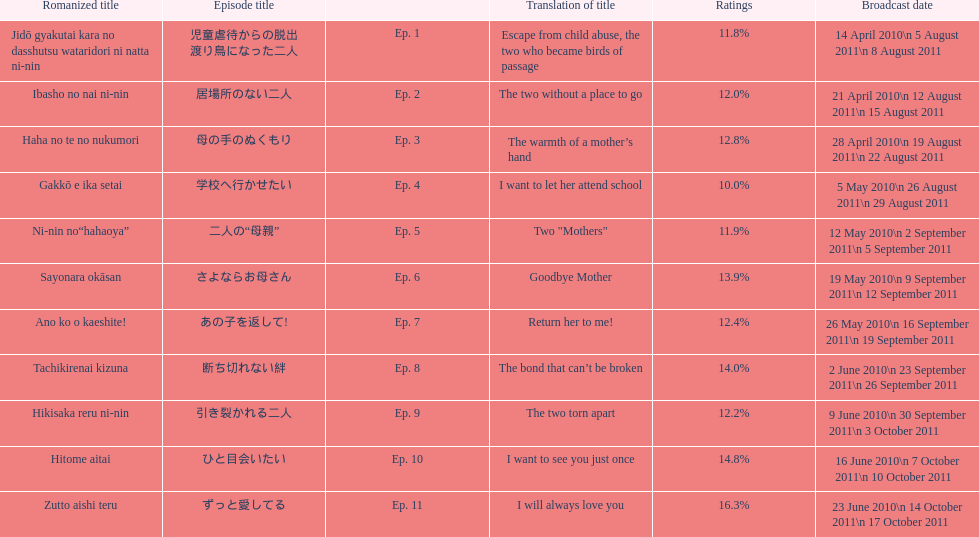Other than the 10th episode, which other episode has a 14% rating? Ep. 8. 